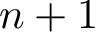<formula> <loc_0><loc_0><loc_500><loc_500>n + 1</formula> 